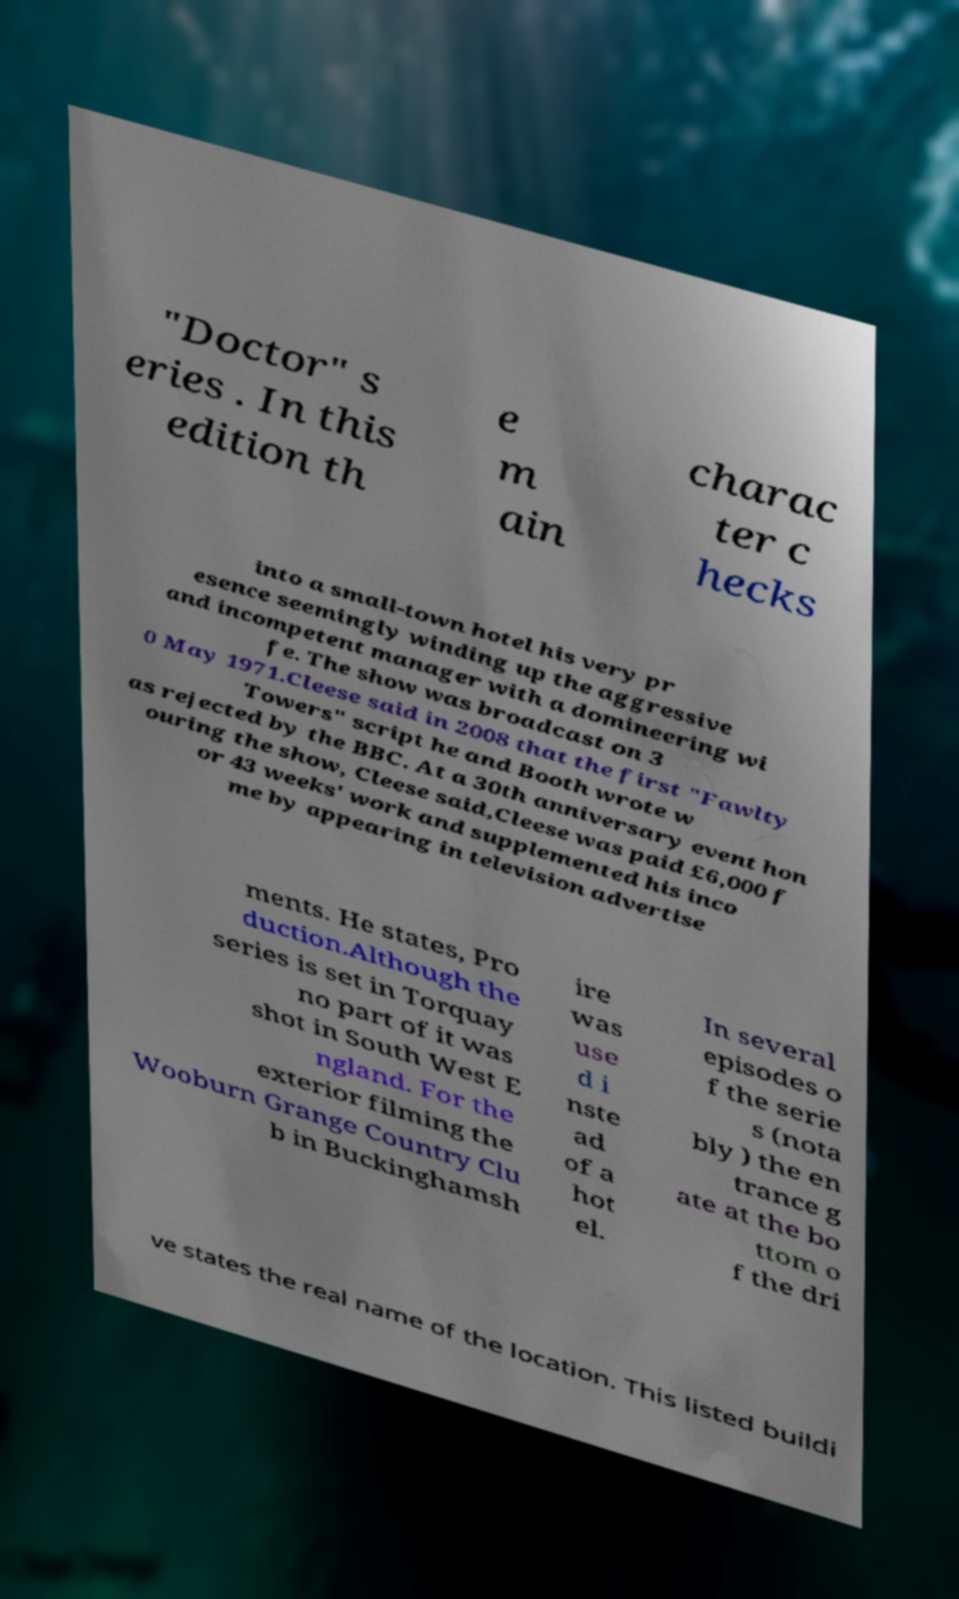Please read and relay the text visible in this image. What does it say? "Doctor" s eries . In this edition th e m ain charac ter c hecks into a small-town hotel his very pr esence seemingly winding up the aggressive and incompetent manager with a domineering wi fe. The show was broadcast on 3 0 May 1971.Cleese said in 2008 that the first "Fawlty Towers" script he and Booth wrote w as rejected by the BBC. At a 30th anniversary event hon ouring the show, Cleese said,Cleese was paid £6,000 f or 43 weeks' work and supplemented his inco me by appearing in television advertise ments. He states, Pro duction.Although the series is set in Torquay no part of it was shot in South West E ngland. For the exterior filming the Wooburn Grange Country Clu b in Buckinghamsh ire was use d i nste ad of a hot el. In several episodes o f the serie s (nota bly ) the en trance g ate at the bo ttom o f the dri ve states the real name of the location. This listed buildi 